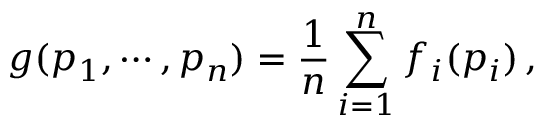<formula> <loc_0><loc_0><loc_500><loc_500>g ( p _ { 1 } , \cdots , p _ { n } ) = \frac { 1 } { n } \sum _ { i = 1 } ^ { n } f _ { i } ( p _ { i } ) \, ,</formula> 